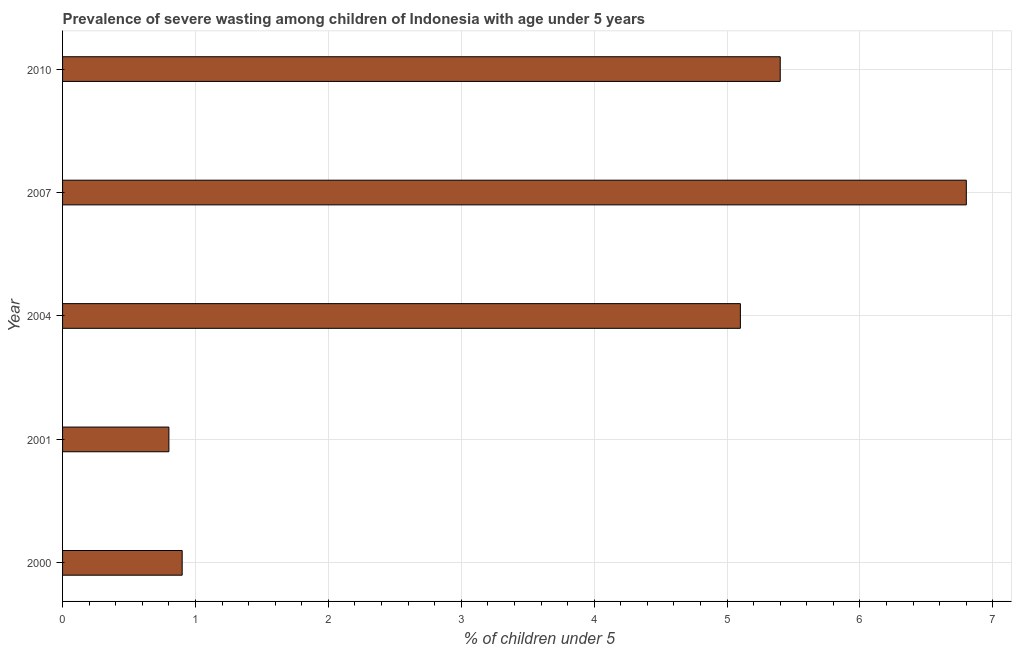What is the title of the graph?
Offer a terse response. Prevalence of severe wasting among children of Indonesia with age under 5 years. What is the label or title of the X-axis?
Your answer should be compact.  % of children under 5. What is the label or title of the Y-axis?
Ensure brevity in your answer.  Year. What is the prevalence of severe wasting in 2010?
Offer a terse response. 5.4. Across all years, what is the maximum prevalence of severe wasting?
Give a very brief answer. 6.8. Across all years, what is the minimum prevalence of severe wasting?
Keep it short and to the point. 0.8. In which year was the prevalence of severe wasting maximum?
Offer a terse response. 2007. In which year was the prevalence of severe wasting minimum?
Make the answer very short. 2001. What is the sum of the prevalence of severe wasting?
Your answer should be compact. 19. What is the difference between the prevalence of severe wasting in 2000 and 2007?
Keep it short and to the point. -5.9. What is the median prevalence of severe wasting?
Give a very brief answer. 5.1. In how many years, is the prevalence of severe wasting greater than 2.6 %?
Give a very brief answer. 3. What is the ratio of the prevalence of severe wasting in 2000 to that in 2007?
Make the answer very short. 0.13. Is the difference between the prevalence of severe wasting in 2004 and 2010 greater than the difference between any two years?
Make the answer very short. No. Is the sum of the prevalence of severe wasting in 2001 and 2010 greater than the maximum prevalence of severe wasting across all years?
Make the answer very short. No. What is the difference between the highest and the lowest prevalence of severe wasting?
Provide a short and direct response. 6. In how many years, is the prevalence of severe wasting greater than the average prevalence of severe wasting taken over all years?
Offer a terse response. 3. How many bars are there?
Give a very brief answer. 5. Are all the bars in the graph horizontal?
Offer a very short reply. Yes. Are the values on the major ticks of X-axis written in scientific E-notation?
Give a very brief answer. No. What is the  % of children under 5 in 2000?
Your answer should be compact. 0.9. What is the  % of children under 5 of 2001?
Your answer should be compact. 0.8. What is the  % of children under 5 of 2004?
Offer a terse response. 5.1. What is the  % of children under 5 of 2007?
Give a very brief answer. 6.8. What is the  % of children under 5 of 2010?
Make the answer very short. 5.4. What is the difference between the  % of children under 5 in 2000 and 2004?
Your answer should be very brief. -4.2. What is the difference between the  % of children under 5 in 2000 and 2007?
Make the answer very short. -5.9. What is the difference between the  % of children under 5 in 2000 and 2010?
Offer a very short reply. -4.5. What is the difference between the  % of children under 5 in 2001 and 2004?
Offer a very short reply. -4.3. What is the difference between the  % of children under 5 in 2001 and 2007?
Offer a terse response. -6. What is the difference between the  % of children under 5 in 2004 and 2007?
Offer a terse response. -1.7. What is the difference between the  % of children under 5 in 2004 and 2010?
Offer a very short reply. -0.3. What is the ratio of the  % of children under 5 in 2000 to that in 2004?
Keep it short and to the point. 0.18. What is the ratio of the  % of children under 5 in 2000 to that in 2007?
Give a very brief answer. 0.13. What is the ratio of the  % of children under 5 in 2000 to that in 2010?
Your response must be concise. 0.17. What is the ratio of the  % of children under 5 in 2001 to that in 2004?
Your response must be concise. 0.16. What is the ratio of the  % of children under 5 in 2001 to that in 2007?
Offer a terse response. 0.12. What is the ratio of the  % of children under 5 in 2001 to that in 2010?
Your answer should be very brief. 0.15. What is the ratio of the  % of children under 5 in 2004 to that in 2010?
Make the answer very short. 0.94. What is the ratio of the  % of children under 5 in 2007 to that in 2010?
Provide a short and direct response. 1.26. 